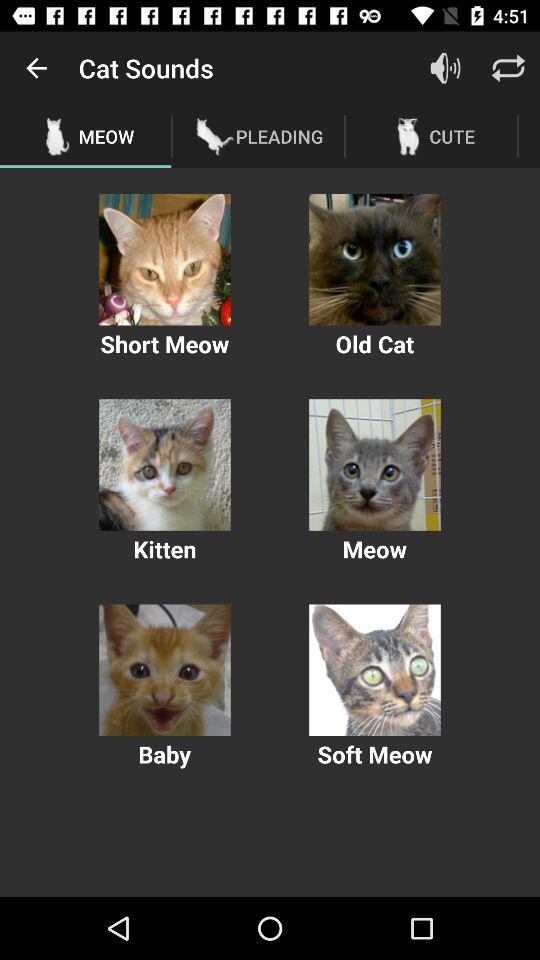Which option in "Cat Sounds" is selected? The selected option is "MEOW". 